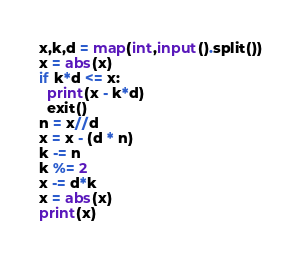Convert code to text. <code><loc_0><loc_0><loc_500><loc_500><_Python_>x,k,d = map(int,input().split())
x = abs(x)
if k*d <= x:
  print(x - k*d)
  exit()
n = x//d
x = x - (d * n)
k -= n
k %= 2
x -= d*k
x = abs(x)
print(x)</code> 